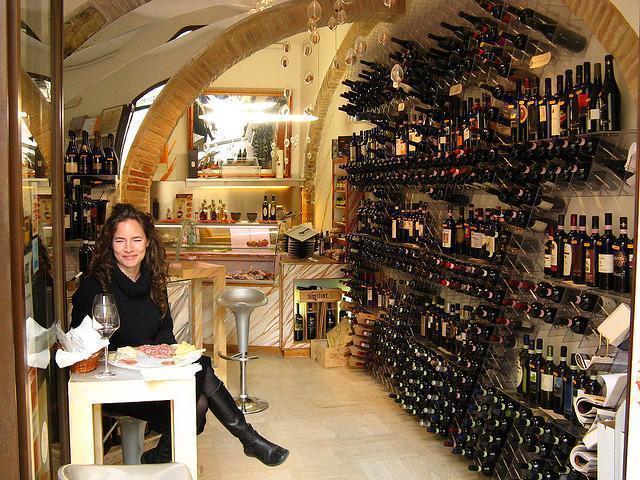What is the woman surrounded by?
Select the correct answer and articulate reasoning with the following format: 'Answer: answer
Rationale: rationale.'
Options: Wine bottles, elk, video games, books. Answer: wine bottles.
Rationale: The objects surrounding the woman are identifiable by their shape and size as well as the labels on them and additionally the glass design the woman is drinking from. 